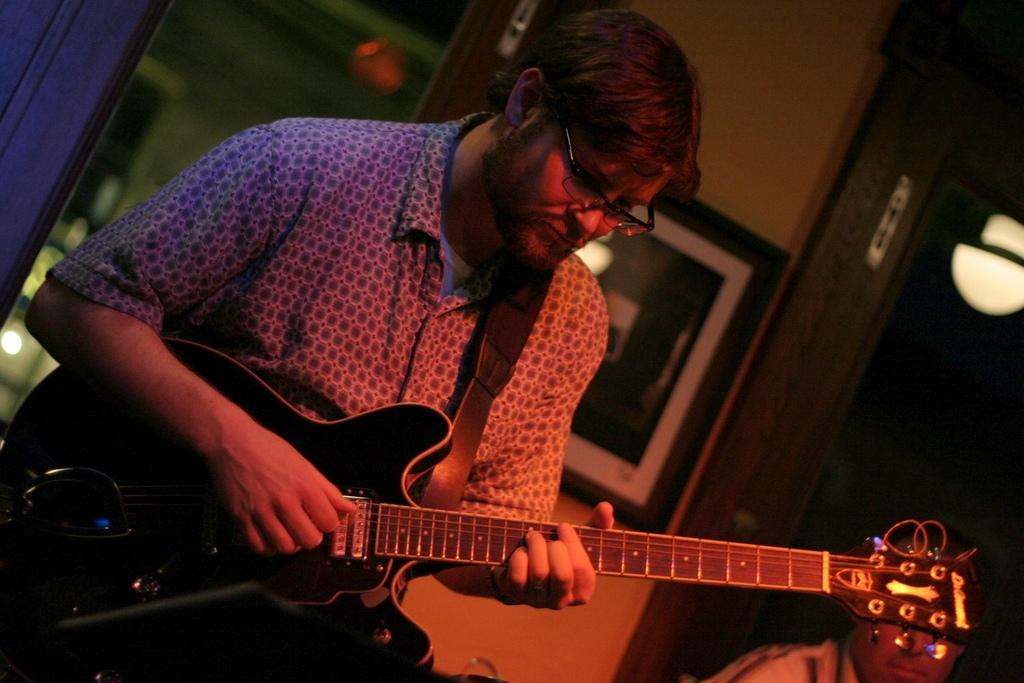What is the man in the image doing? The man is playing the guitar. What object is the man holding in the image? The man is holding a guitar. Can you describe the background of the image? There is a person in the background of the image, and there is a photo frame on the wall. What type of letters is the man receiving in the image? There are no letters present in the image; the man is playing the guitar. What is the condition of the roof in the image? There is no roof visible in the image, as it appears to be an indoor setting. 